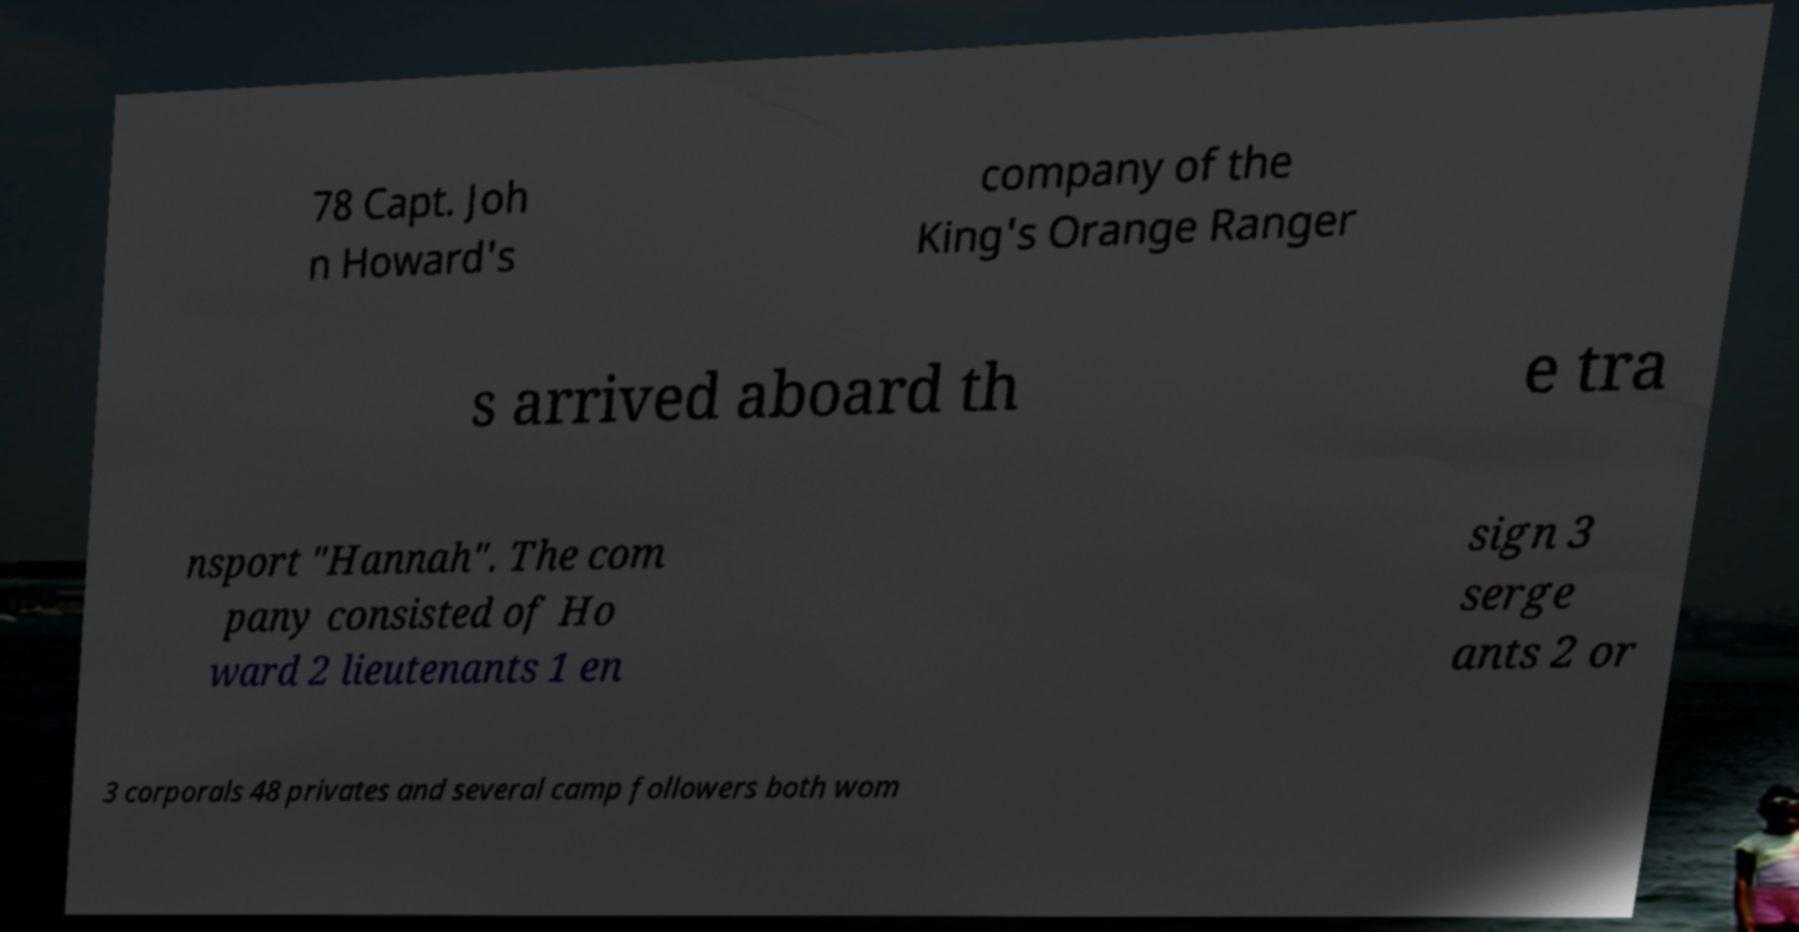Can you read and provide the text displayed in the image?This photo seems to have some interesting text. Can you extract and type it out for me? 78 Capt. Joh n Howard's company of the King's Orange Ranger s arrived aboard th e tra nsport "Hannah". The com pany consisted of Ho ward 2 lieutenants 1 en sign 3 serge ants 2 or 3 corporals 48 privates and several camp followers both wom 